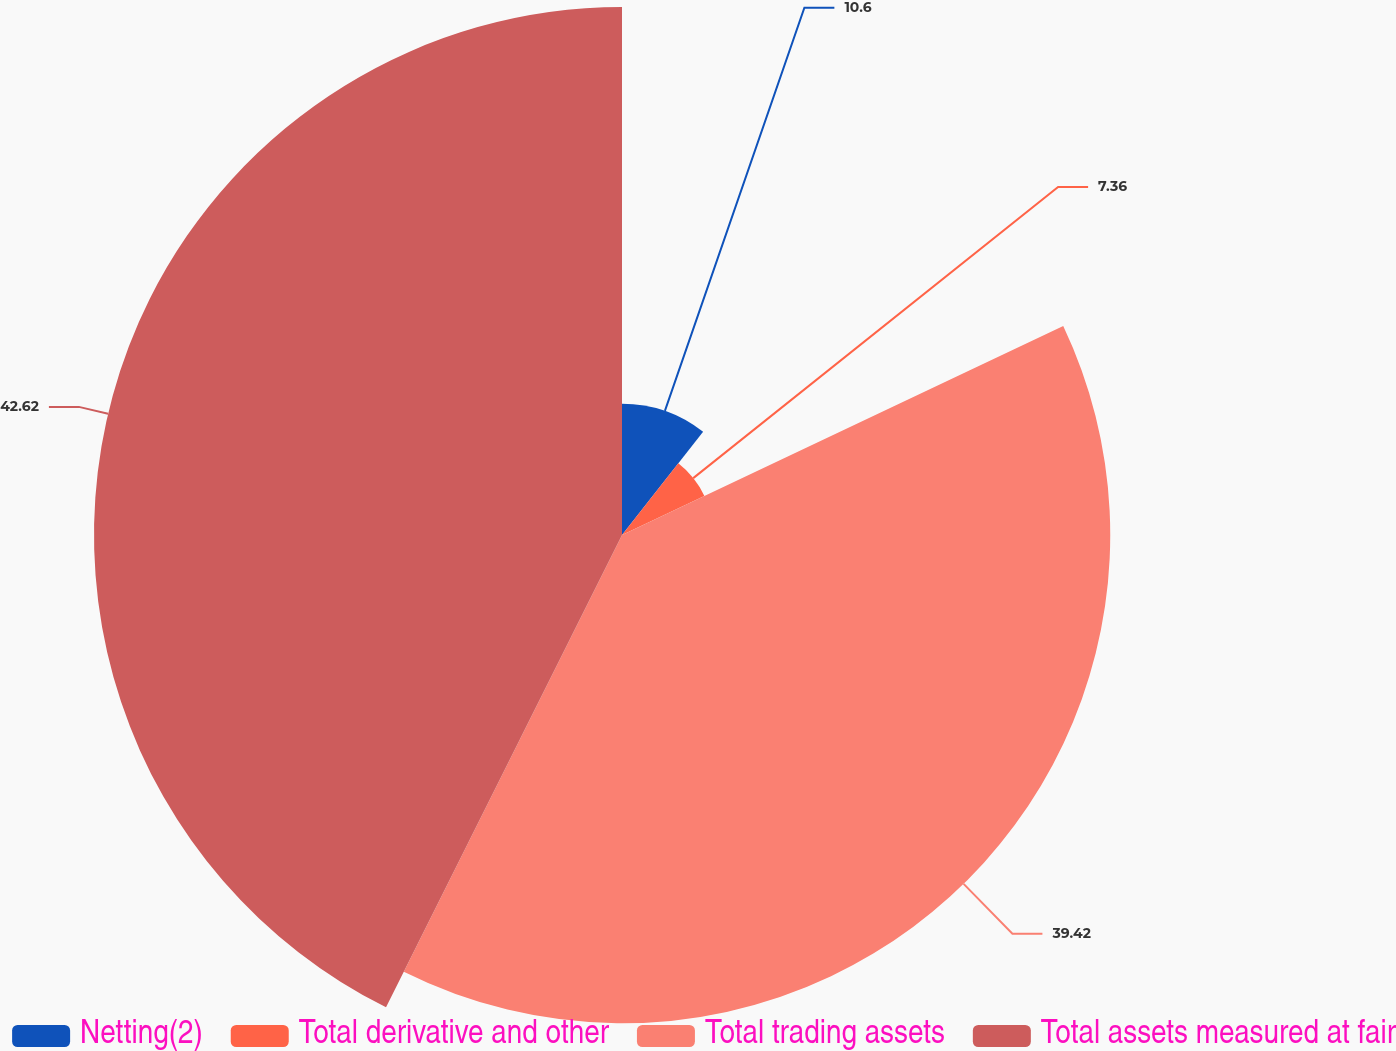Convert chart to OTSL. <chart><loc_0><loc_0><loc_500><loc_500><pie_chart><fcel>Netting(2)<fcel>Total derivative and other<fcel>Total trading assets<fcel>Total assets measured at fair<nl><fcel>10.6%<fcel>7.36%<fcel>39.42%<fcel>42.63%<nl></chart> 